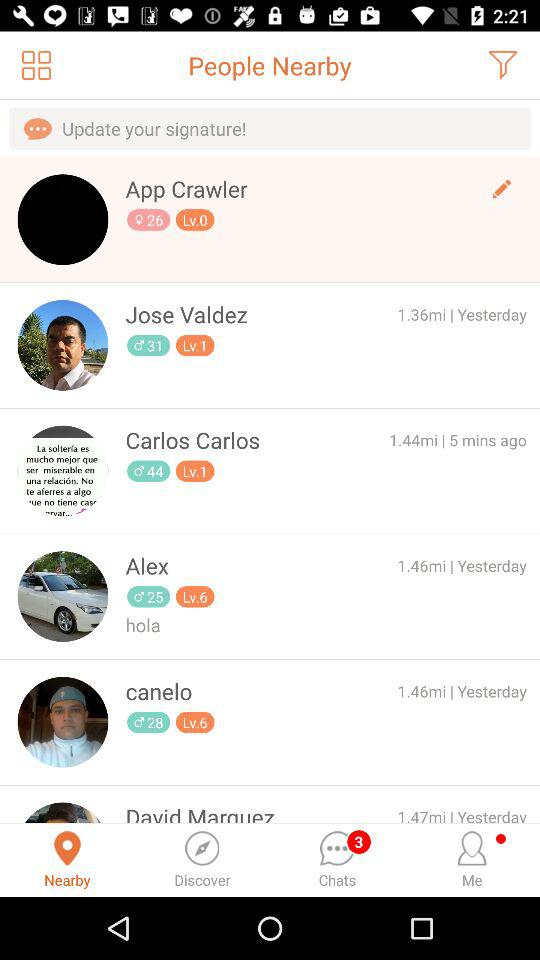How far is Alex? Alex is 1.46 miles away. 